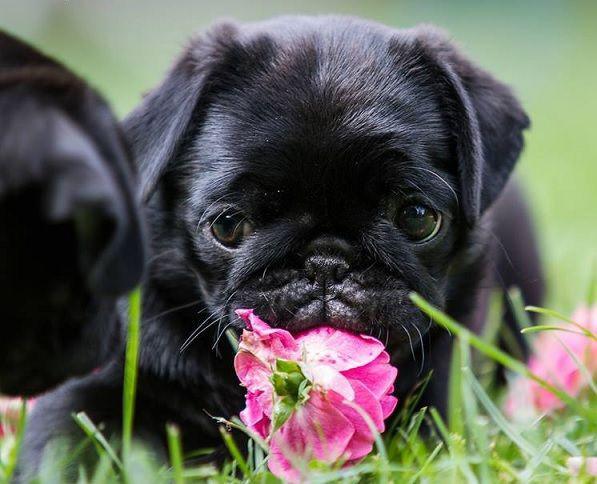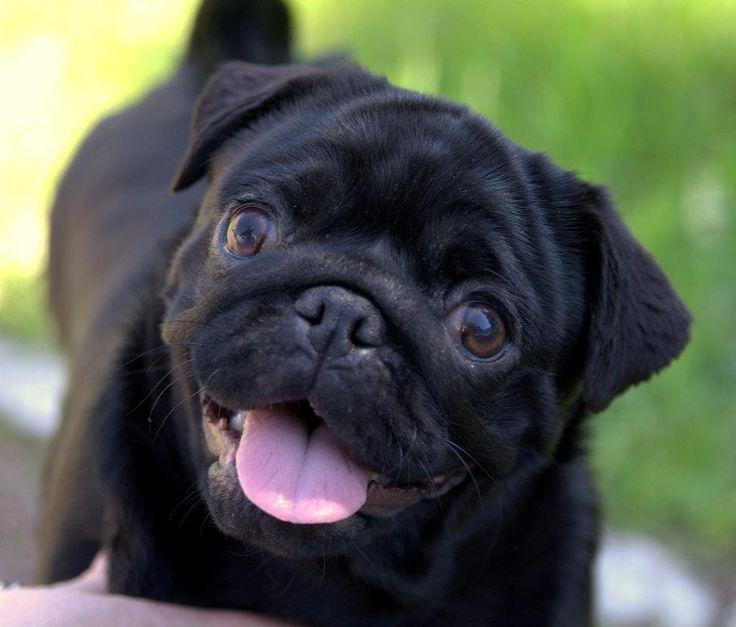The first image is the image on the left, the second image is the image on the right. Given the left and right images, does the statement "In one image there is one black pug and at least one flower visible" hold true? Answer yes or no. Yes. The first image is the image on the left, the second image is the image on the right. Considering the images on both sides, is "An image features two different-colored pug dogs posing together in the grass." valid? Answer yes or no. No. 